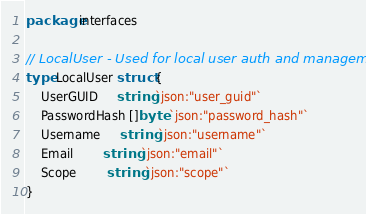<code> <loc_0><loc_0><loc_500><loc_500><_Go_>package interfaces

// LocalUser - Used for local user auth and management
type LocalUser struct {
	UserGUID     string `json:"user_guid"`
	PasswordHash []byte `json:"password_hash"`
	Username     string `json:"username"`
	Email        string `json:"email"`
	Scope        string `json:"scope"`
}
</code> 